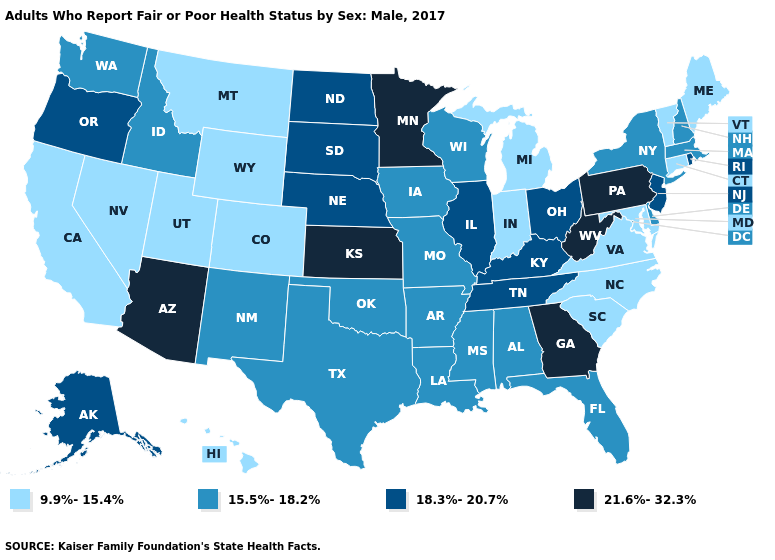Among the states that border Vermont , which have the lowest value?
Give a very brief answer. Massachusetts, New Hampshire, New York. Name the states that have a value in the range 18.3%-20.7%?
Quick response, please. Alaska, Illinois, Kentucky, Nebraska, New Jersey, North Dakota, Ohio, Oregon, Rhode Island, South Dakota, Tennessee. Among the states that border Kentucky , which have the lowest value?
Answer briefly. Indiana, Virginia. What is the value of West Virginia?
Concise answer only. 21.6%-32.3%. Name the states that have a value in the range 15.5%-18.2%?
Keep it brief. Alabama, Arkansas, Delaware, Florida, Idaho, Iowa, Louisiana, Massachusetts, Mississippi, Missouri, New Hampshire, New Mexico, New York, Oklahoma, Texas, Washington, Wisconsin. Does Indiana have the same value as Georgia?
Concise answer only. No. Which states hav the highest value in the Northeast?
Quick response, please. Pennsylvania. What is the value of Utah?
Give a very brief answer. 9.9%-15.4%. Which states have the highest value in the USA?
Answer briefly. Arizona, Georgia, Kansas, Minnesota, Pennsylvania, West Virginia. What is the value of Arizona?
Answer briefly. 21.6%-32.3%. Does the first symbol in the legend represent the smallest category?
Write a very short answer. Yes. Name the states that have a value in the range 21.6%-32.3%?
Write a very short answer. Arizona, Georgia, Kansas, Minnesota, Pennsylvania, West Virginia. Does Minnesota have the lowest value in the USA?
Quick response, please. No. What is the value of Maine?
Write a very short answer. 9.9%-15.4%. What is the highest value in the USA?
Short answer required. 21.6%-32.3%. 